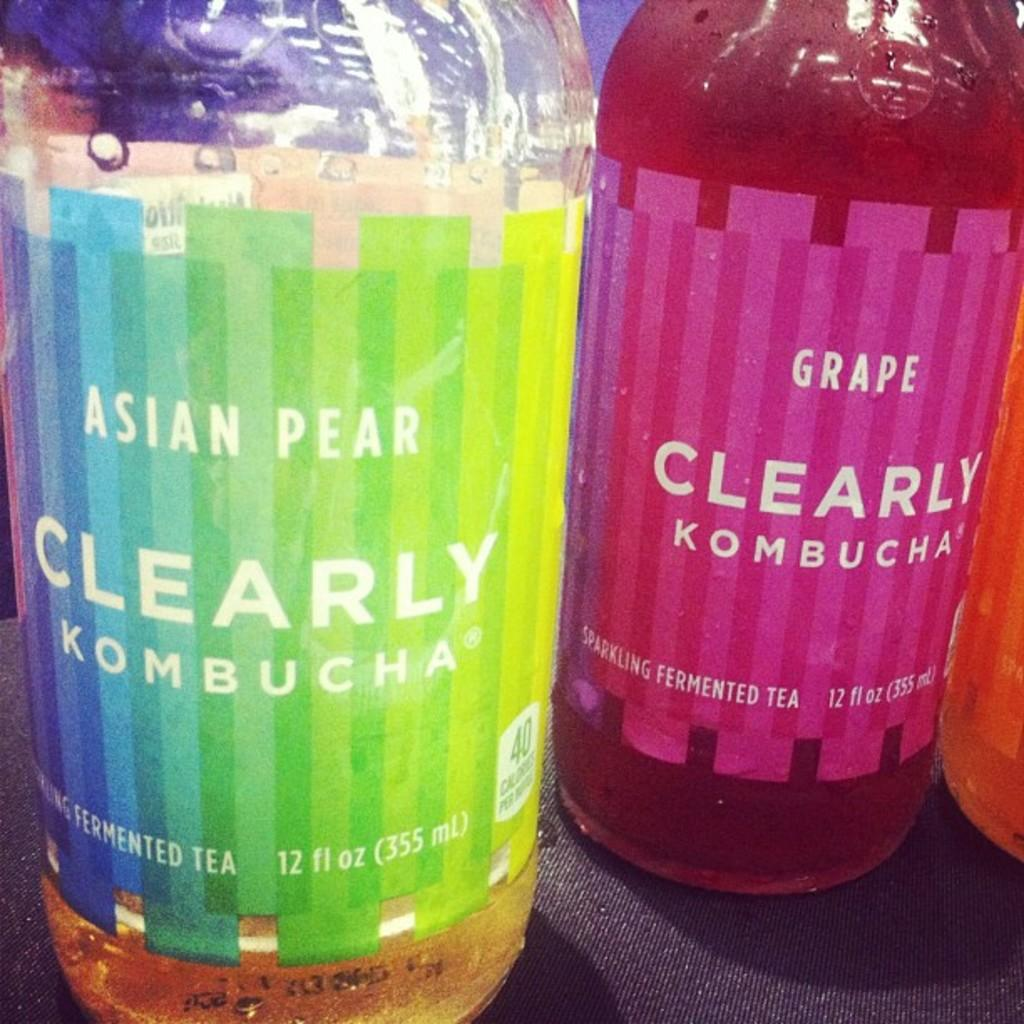Provide a one-sentence caption for the provided image. Two bottles of kombucha are adjacent to each other. 